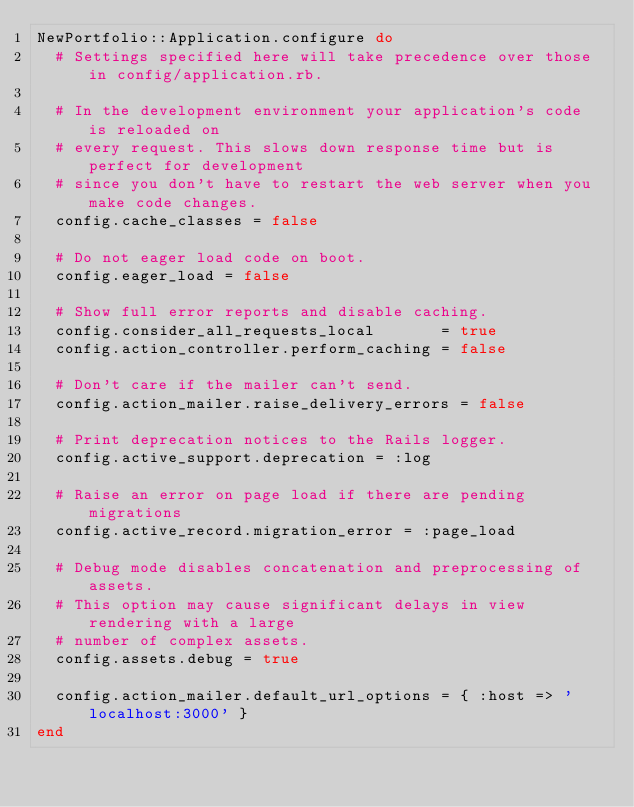<code> <loc_0><loc_0><loc_500><loc_500><_Ruby_>NewPortfolio::Application.configure do
  # Settings specified here will take precedence over those in config/application.rb.

  # In the development environment your application's code is reloaded on
  # every request. This slows down response time but is perfect for development
  # since you don't have to restart the web server when you make code changes.
  config.cache_classes = false

  # Do not eager load code on boot.
  config.eager_load = false

  # Show full error reports and disable caching.
  config.consider_all_requests_local       = true
  config.action_controller.perform_caching = false

  # Don't care if the mailer can't send.
  config.action_mailer.raise_delivery_errors = false

  # Print deprecation notices to the Rails logger.
  config.active_support.deprecation = :log

  # Raise an error on page load if there are pending migrations
  config.active_record.migration_error = :page_load

  # Debug mode disables concatenation and preprocessing of assets.
  # This option may cause significant delays in view rendering with a large
  # number of complex assets.
  config.assets.debug = true

  config.action_mailer.default_url_options = { :host => 'localhost:3000' }
end
</code> 